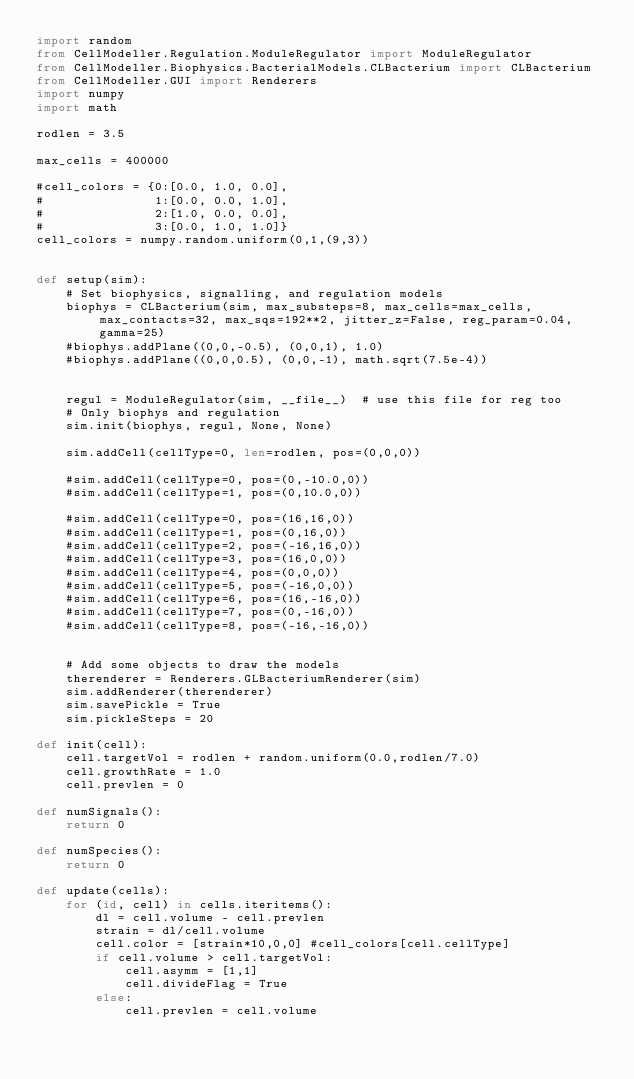<code> <loc_0><loc_0><loc_500><loc_500><_Python_>import random
from CellModeller.Regulation.ModuleRegulator import ModuleRegulator
from CellModeller.Biophysics.BacterialModels.CLBacterium import CLBacterium
from CellModeller.GUI import Renderers
import numpy
import math

rodlen = 3.5 

max_cells = 400000

#cell_colors = {0:[0.0, 1.0, 0.0],
#               1:[0.0, 0.0, 1.0],
#               2:[1.0, 0.0, 0.0],
#               3:[0.0, 1.0, 1.0]}
cell_colors = numpy.random.uniform(0,1,(9,3))


def setup(sim):
    # Set biophysics, signalling, and regulation models
    biophys = CLBacterium(sim, max_substeps=8, max_cells=max_cells, max_contacts=32, max_sqs=192**2, jitter_z=False, reg_param=0.04, gamma=25)
    #biophys.addPlane((0,0,-0.5), (0,0,1), 1.0)
    #biophys.addPlane((0,0,0.5), (0,0,-1), math.sqrt(7.5e-4))


    regul = ModuleRegulator(sim, __file__)	# use this file for reg too
    # Only biophys and regulation
    sim.init(biophys, regul, None, None)

    sim.addCell(cellType=0, len=rodlen, pos=(0,0,0))

    #sim.addCell(cellType=0, pos=(0,-10.0,0))
    #sim.addCell(cellType=1, pos=(0,10.0,0))

    #sim.addCell(cellType=0, pos=(16,16,0))
    #sim.addCell(cellType=1, pos=(0,16,0))
    #sim.addCell(cellType=2, pos=(-16,16,0))
    #sim.addCell(cellType=3, pos=(16,0,0))
    #sim.addCell(cellType=4, pos=(0,0,0))
    #sim.addCell(cellType=5, pos=(-16,0,0))
    #sim.addCell(cellType=6, pos=(16,-16,0))
    #sim.addCell(cellType=7, pos=(0,-16,0))
    #sim.addCell(cellType=8, pos=(-16,-16,0))


    # Add some objects to draw the models
    therenderer = Renderers.GLBacteriumRenderer(sim)
    sim.addRenderer(therenderer)
    sim.savePickle = True
    sim.pickleSteps = 20

def init(cell):
    cell.targetVol = rodlen + random.uniform(0.0,rodlen/7.0)
    cell.growthRate = 1.0 
    cell.prevlen = 0

def numSignals():
    return 0

def numSpecies():
    return 0

def update(cells):
    for (id, cell) in cells.iteritems():
        dl = cell.volume - cell.prevlen
        strain = dl/cell.volume
        cell.color = [strain*10,0,0] #cell_colors[cell.cellType]
        if cell.volume > cell.targetVol:
            cell.asymm = [1,1]
            cell.divideFlag = True
        else:
            cell.prevlen = cell.volume
</code> 